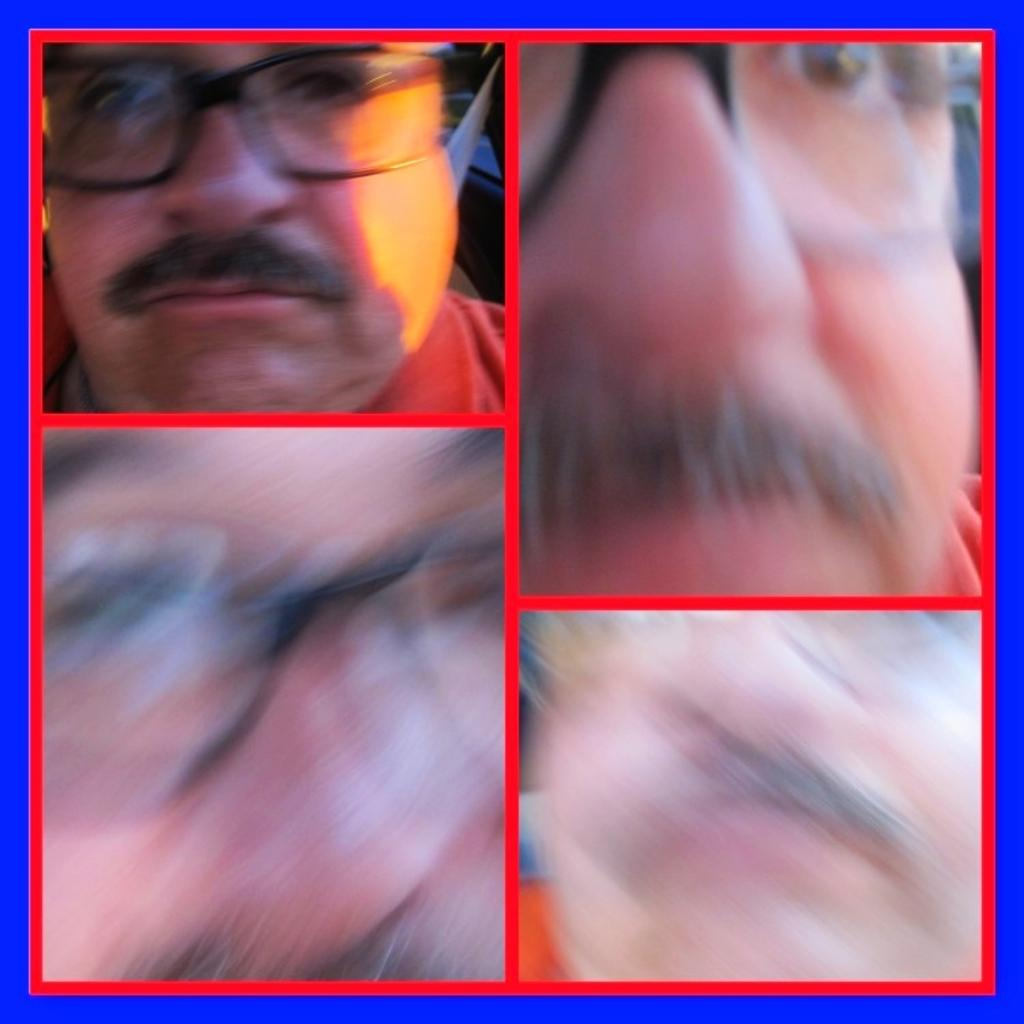What is the main subject of the image? The main subject of the image is a person's face. How is the person's face presented in the image? The image is a collage of the person's face. What type of animal is featured in the person's sister's soap commercial? There is no animal, sister, or soap commercial present in the image; it is a collage of a person's face. 